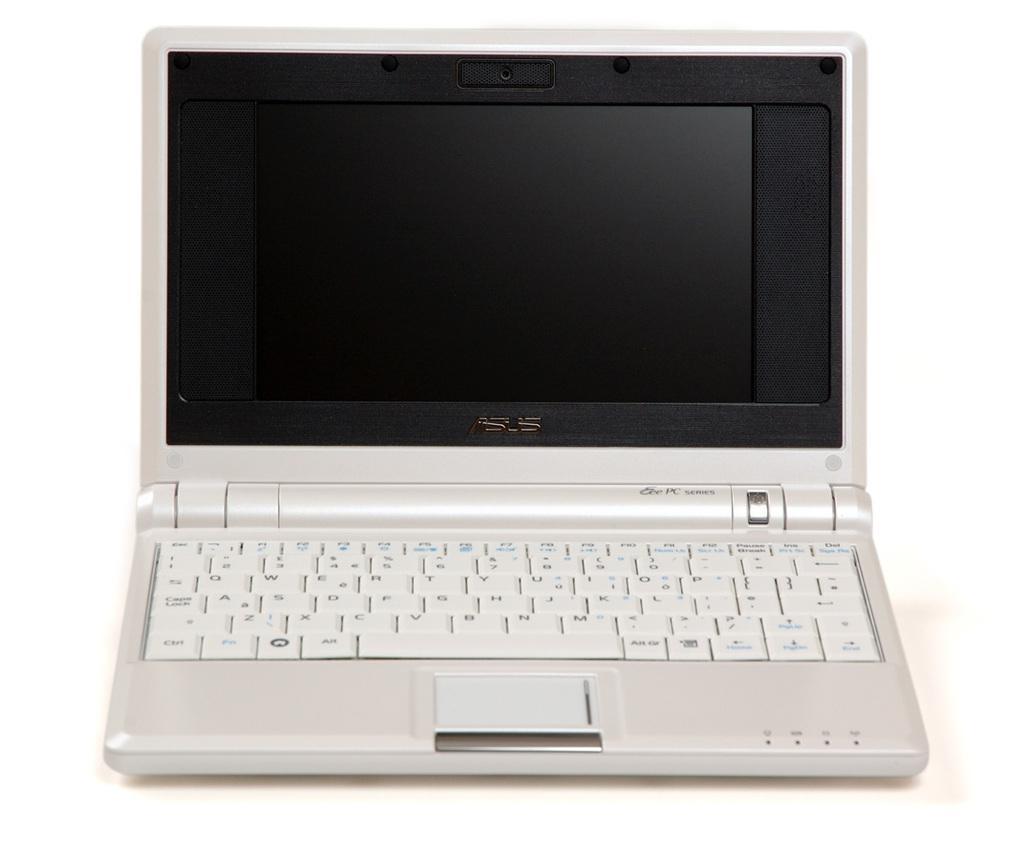Please provide a concise description of this image. In this image there is a laptop. 